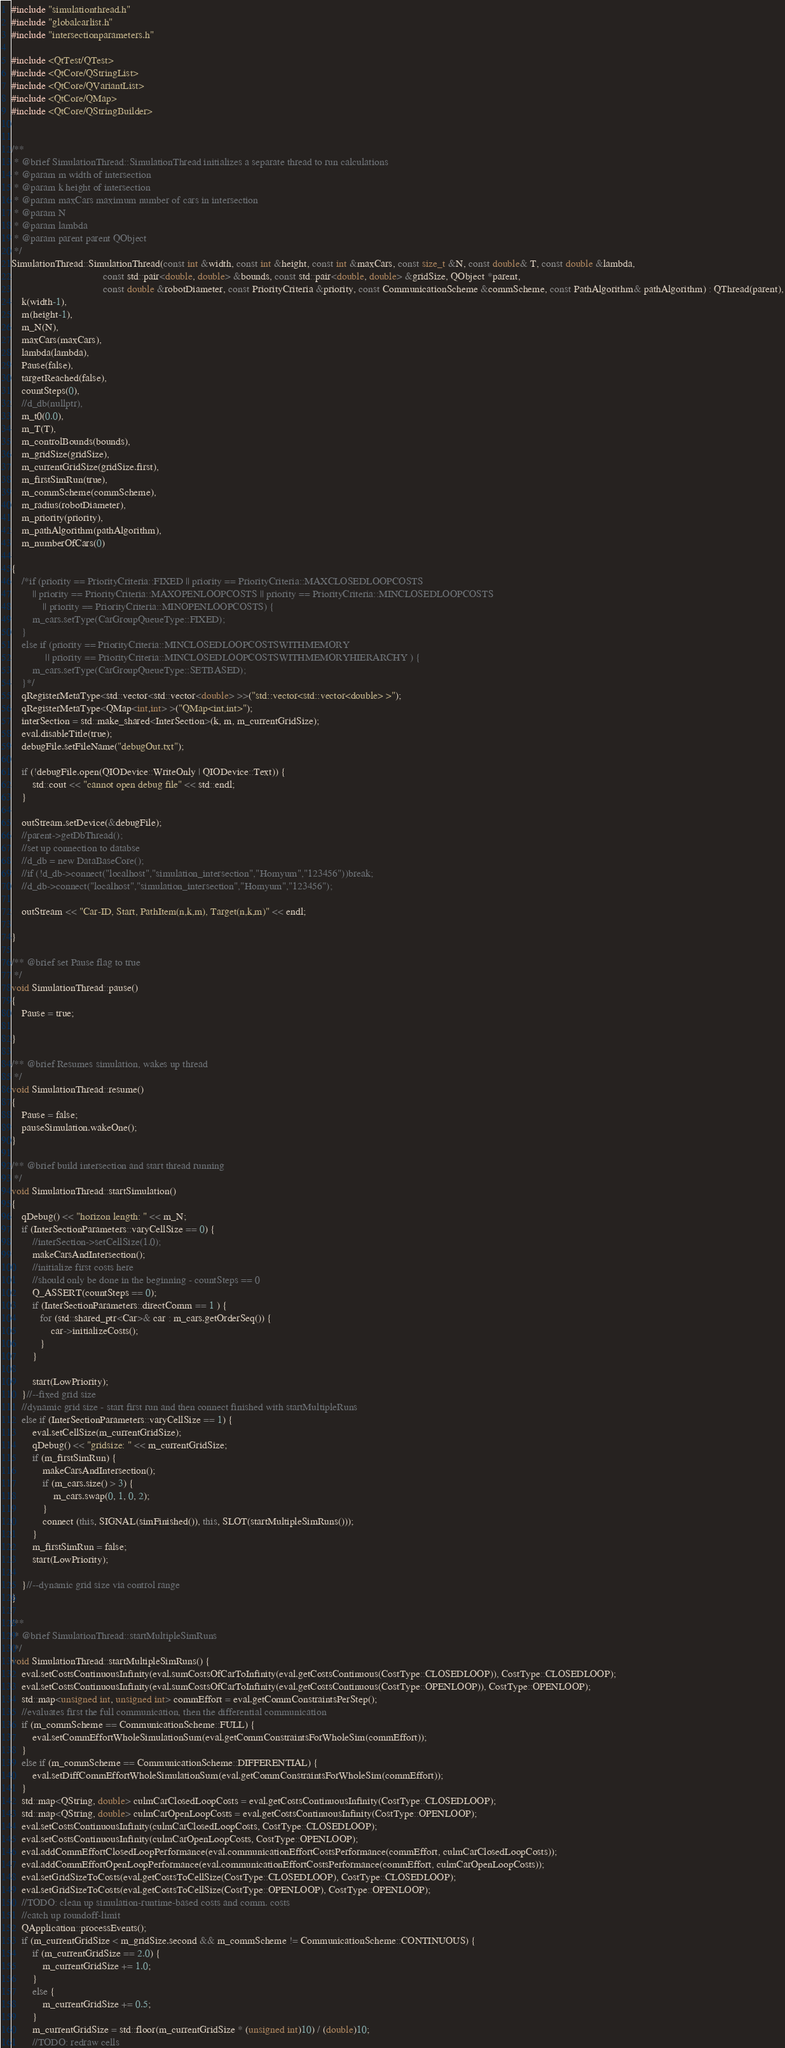<code> <loc_0><loc_0><loc_500><loc_500><_C++_>#include "simulationthread.h"
#include "globalcarlist.h"
#include "intersectionparameters.h"

#include <QtTest/QTest>
#include <QtCore/QStringList>
#include <QtCore/QVariantList>
#include <QtCore/QMap>
#include <QtCore/QStringBuilder>


/**
 * @brief SimulationThread::SimulationThread initializes a separate thread to run calculations
 * @param m width of intersection
 * @param k height of intersection
 * @param maxCars maximum number of cars in intersection
 * @param N
 * @param lambda
 * @param parent parent QObject
 */
SimulationThread::SimulationThread(const int &width, const int &height, const int &maxCars, const size_t &N, const double& T, const double &lambda,
                                   const std::pair<double, double> &bounds, const std::pair<double, double> &gridSize, QObject *parent,
                                   const double &robotDiameter, const PriorityCriteria &priority, const CommunicationScheme &commScheme, const PathAlgorithm& pathAlgorithm) : QThread(parent),
    k(width-1),
    m(height-1),
    m_N(N),
    maxCars(maxCars),
    lambda(lambda),
    Pause(false),
    targetReached(false),
    countSteps(0),
    //d_db(nullptr),
    m_t0(0.0),
    m_T(T),
    m_controlBounds(bounds),
    m_gridSize(gridSize),
    m_currentGridSize(gridSize.first),
    m_firstSimRun(true),
    m_commScheme(commScheme),
    m_radius(robotDiameter),
    m_priority(priority),
    m_pathAlgorithm(pathAlgorithm),
    m_numberOfCars(0)

{
    /*if (priority == PriorityCriteria::FIXED || priority == PriorityCriteria::MAXCLOSEDLOOPCOSTS
        || priority == PriorityCriteria::MAXOPENLOOPCOSTS || priority == PriorityCriteria::MINCLOSEDLOOPCOSTS
            || priority == PriorityCriteria::MINOPENLOOPCOSTS) {
        m_cars.setType(CarGroupQueueType::FIXED);
    }
    else if (priority == PriorityCriteria::MINCLOSEDLOOPCOSTSWITHMEMORY
             || priority == PriorityCriteria::MINCLOSEDLOOPCOSTSWITHMEMORYHIERARCHY ) {
        m_cars.setType(CarGroupQueueType::SETBASED);
    }*/
    qRegisterMetaType<std::vector<std::vector<double> >>("std::vector<std::vector<double> >");
    qRegisterMetaType<QMap<int,int> >("QMap<int,int>");
    interSection = std::make_shared<InterSection>(k, m, m_currentGridSize);
    eval.disableTitle(true);
    debugFile.setFileName("debugOut.txt");

    if (!debugFile.open(QIODevice::WriteOnly | QIODevice::Text)) {
        std::cout << "cannot open debug file" << std::endl;
    }

    outStream.setDevice(&debugFile);
    //parent->getDbThread();
    //set up connection to databse
    //d_db = new DataBaseCore();
    //if (!d_db->connect("localhost","simulation_intersection","Homyum","123456"))break;
    //d_db->connect("localhost","simulation_intersection","Homyum","123456");

    outStream << "Car-ID, Start, PathItem(n,k,m), Target(n,k,m)" << endl;

}

/** @brief set Pause flag to true
 */
void SimulationThread::pause()
{
    Pause = true;

}

/** @brief Resumes simulation, wakes up thread
 */
void SimulationThread::resume()
{
    Pause = false;
    pauseSimulation.wakeOne();
}

/** @brief build intersection and start thread running
 */
void SimulationThread::startSimulation()
{
    qDebug() << "horizon length: " << m_N;
    if (InterSectionParameters::varyCellSize == 0) {
        //interSection->setCellSize(1.0);
        makeCarsAndIntersection();
        //initialize first costs here
        //should only be done in the beginning - countSteps == 0
        Q_ASSERT(countSteps == 0);
        if (InterSectionParameters::directComm == 1 ) {
           for (std::shared_ptr<Car>& car : m_cars.getOrderSeq()) {
               car->initializeCosts();
           }
        }

        start(LowPriority);
    }//--fixed grid size
    //dynamic grid size - start first run and then connect finished with startMultipleRuns
    else if (InterSectionParameters::varyCellSize == 1) {
        eval.setCellSize(m_currentGridSize);
        qDebug() << "gridsize: " << m_currentGridSize;
        if (m_firstSimRun) {
            makeCarsAndIntersection();
            if (m_cars.size() > 3) {
                m_cars.swap(0, 1, 0, 2);
            }
            connect (this, SIGNAL(simFinished()), this, SLOT(startMultipleSimRuns()));
        }
        m_firstSimRun = false;
        start(LowPriority);

    }//--dynamic grid size via control range
}

/**
 * @brief SimulationThread::startMultipleSimRuns
 */
void SimulationThread::startMultipleSimRuns() {
    eval.setCostsContinuousInfinity(eval.sumCostsOfCarToInfinity(eval.getCostsContinuous(CostType::CLOSEDLOOP)), CostType::CLOSEDLOOP);
    eval.setCostsContinuousInfinity(eval.sumCostsOfCarToInfinity(eval.getCostsContinuous(CostType::OPENLOOP)), CostType::OPENLOOP);
    std::map<unsigned int, unsigned int> commEffort = eval.getCommConstraintsPerStep();
    //evaluates first the full communication, then the differential communication
    if (m_commScheme == CommunicationScheme::FULL) {
        eval.setCommEffortWholeSimulationSum(eval.getCommConstraintsForWholeSim(commEffort));
    }
    else if (m_commScheme == CommunicationScheme::DIFFERENTIAL) {
        eval.setDiffCommEffortWholeSimulationSum(eval.getCommConstraintsForWholeSim(commEffort));
    }
    std::map<QString, double> culmCarClosedLoopCosts = eval.getCostsContinuousInfinity(CostType::CLOSEDLOOP);
    std::map<QString, double> culmCarOpenLoopCosts = eval.getCostsContinuousInfinity(CostType::OPENLOOP);
    eval.setCostsContinuousInfinity(culmCarClosedLoopCosts, CostType::CLOSEDLOOP);
    eval.setCostsContinuousInfinity(culmCarOpenLoopCosts, CostType::OPENLOOP);
    eval.addCommEffortClosedLoopPerformance(eval.communicationEffortCostsPerformance(commEffort, culmCarClosedLoopCosts));
    eval.addCommEffortOpenLoopPerformance(eval.communicationEffortCostsPerformance(commEffort, culmCarOpenLoopCosts));
    eval.setGridSizeToCosts(eval.getCostsToCellSize(CostType::CLOSEDLOOP), CostType::CLOSEDLOOP);
    eval.setGridSizeToCosts(eval.getCostsToCellSize(CostType::OPENLOOP), CostType::OPENLOOP);
    //TODO: clean up simulation-runtime-based costs and comm. costs
    //catch up roundoff-limit
    QApplication::processEvents();
    if (m_currentGridSize < m_gridSize.second && m_commScheme != CommunicationScheme::CONTINUOUS) {
        if (m_currentGridSize == 2.0) {
            m_currentGridSize += 1.0;
        }
        else {
            m_currentGridSize += 0.5;
        }
        m_currentGridSize = std::floor(m_currentGridSize * (unsigned int)10) / (double)10;
        //TODO: redraw cells</code> 